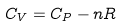<formula> <loc_0><loc_0><loc_500><loc_500>C _ { V } = C _ { P } - n R</formula> 